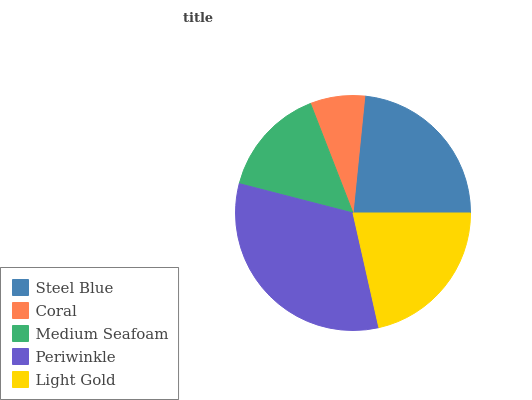Is Coral the minimum?
Answer yes or no. Yes. Is Periwinkle the maximum?
Answer yes or no. Yes. Is Medium Seafoam the minimum?
Answer yes or no. No. Is Medium Seafoam the maximum?
Answer yes or no. No. Is Medium Seafoam greater than Coral?
Answer yes or no. Yes. Is Coral less than Medium Seafoam?
Answer yes or no. Yes. Is Coral greater than Medium Seafoam?
Answer yes or no. No. Is Medium Seafoam less than Coral?
Answer yes or no. No. Is Light Gold the high median?
Answer yes or no. Yes. Is Light Gold the low median?
Answer yes or no. Yes. Is Coral the high median?
Answer yes or no. No. Is Medium Seafoam the low median?
Answer yes or no. No. 